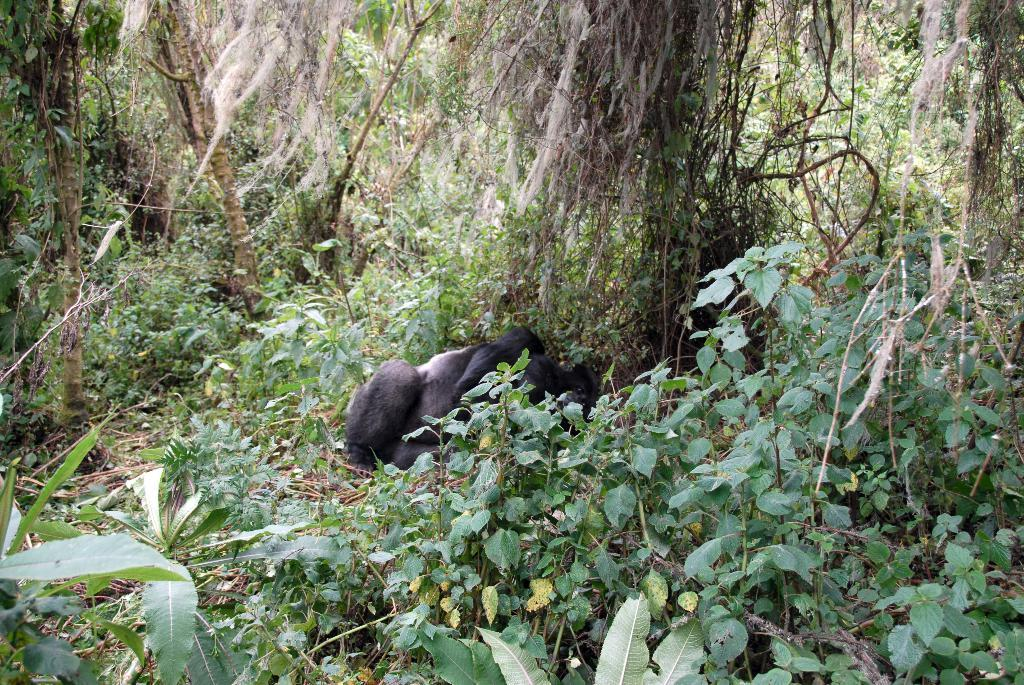What is the main subject in the center of the image? There is a monkey in the center of the image. What can be seen in the background or surrounding the main subject? There is greenery around the area of the image. What type of guitar is the monkey playing in the image? There is no guitar present in the image; the monkey is not playing any instrument. 